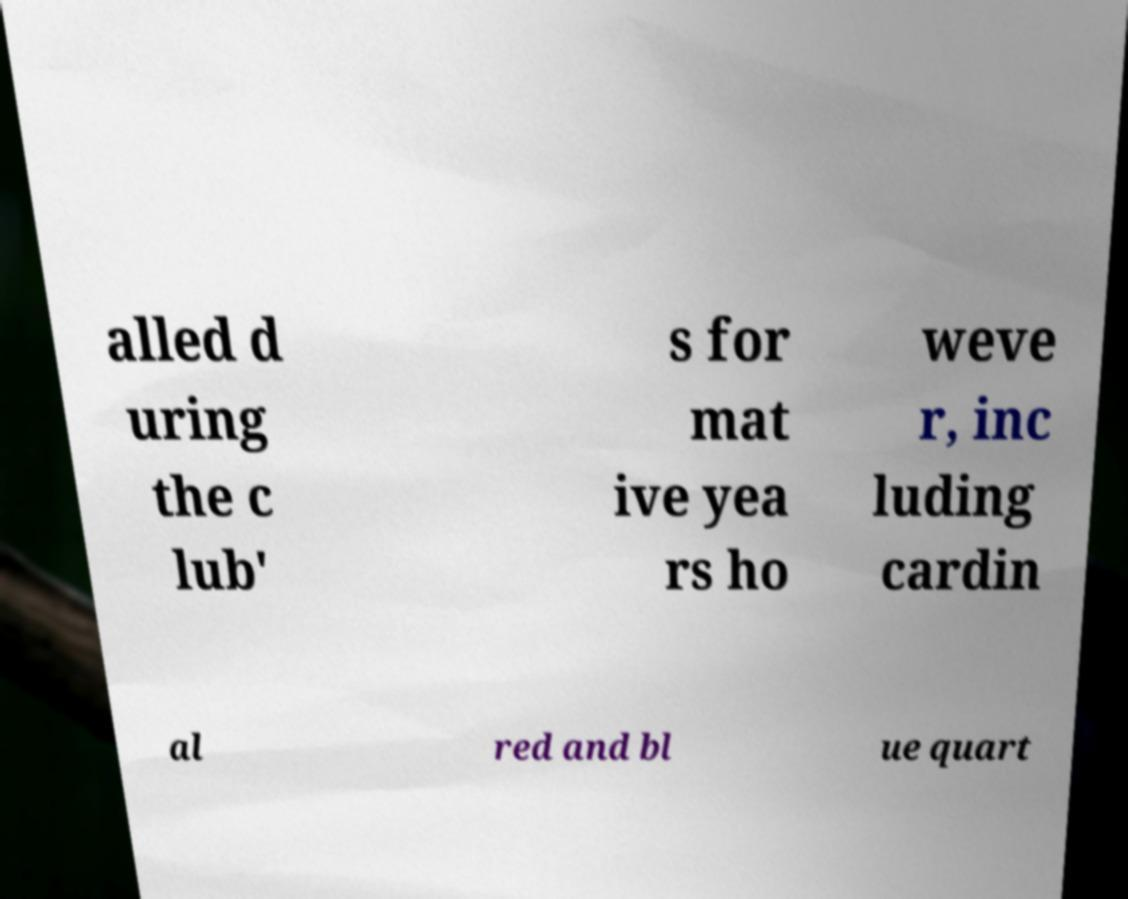Can you accurately transcribe the text from the provided image for me? alled d uring the c lub' s for mat ive yea rs ho weve r, inc luding cardin al red and bl ue quart 